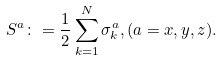<formula> <loc_0><loc_0><loc_500><loc_500>S ^ { a } \colon = \frac { 1 } { 2 } \sum _ { k = 1 } ^ { N } \sigma _ { k } ^ { a } , ( a = x , y , z ) .</formula> 